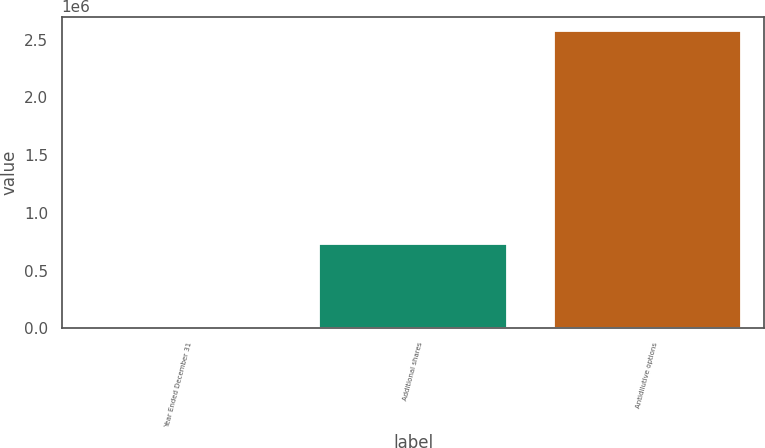<chart> <loc_0><loc_0><loc_500><loc_500><bar_chart><fcel>Year Ended December 31<fcel>Additional shares<fcel>Antidilutive options<nl><fcel>2012<fcel>730000<fcel>2.572e+06<nl></chart> 